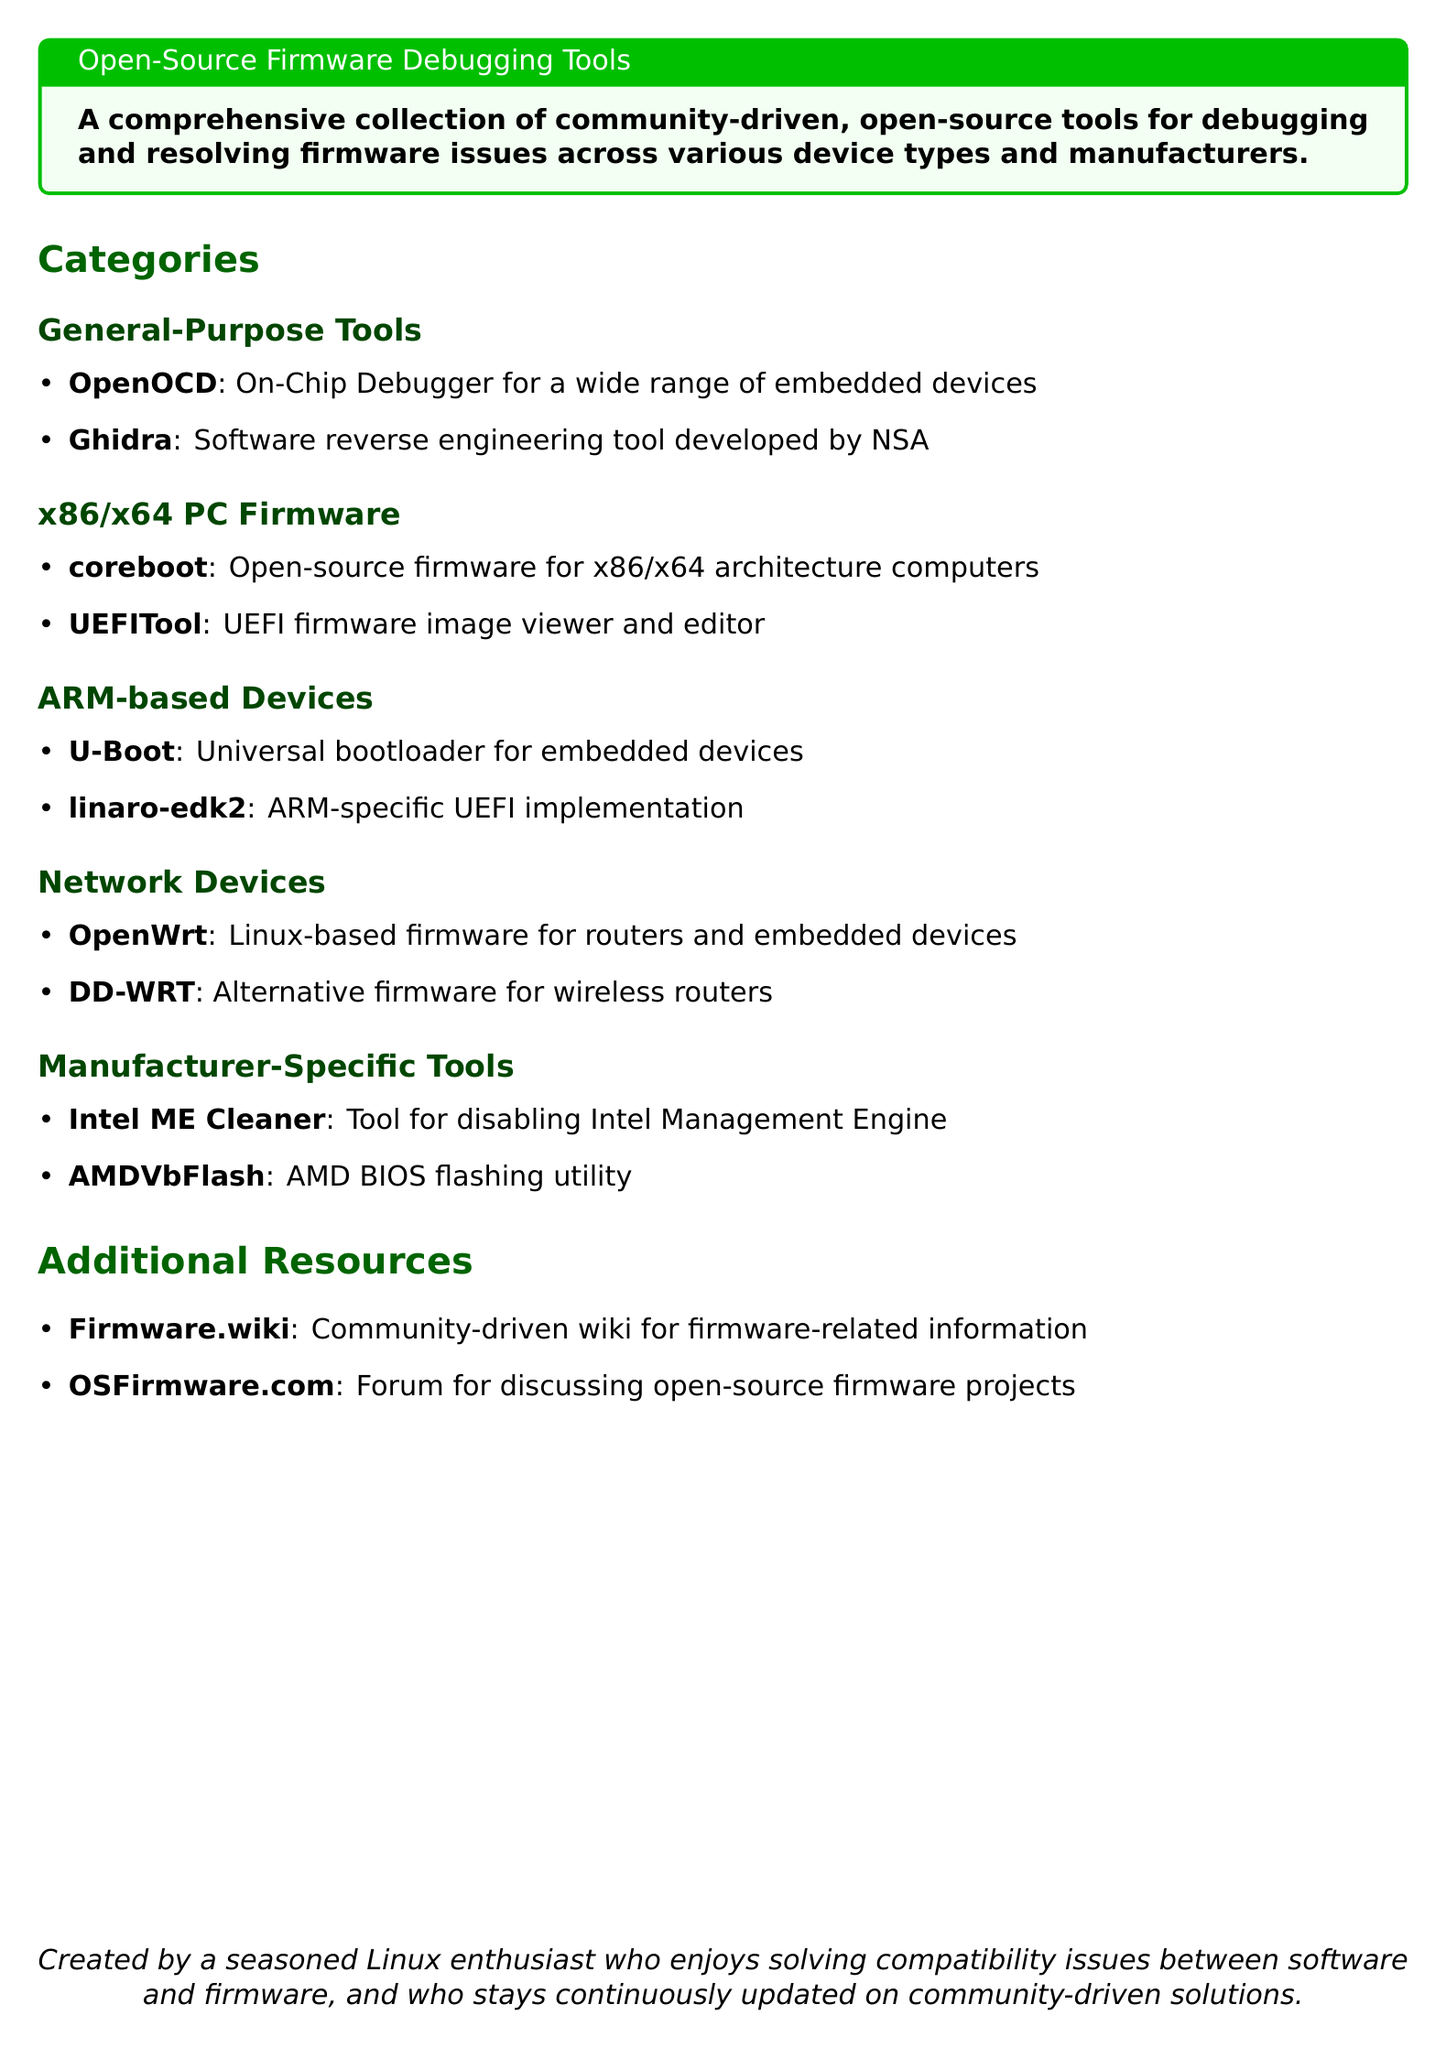What is the title of the document? The title is provided in the header of the document and describes the content, which is "Open-Source Firmware Debugging Tools."
Answer: Open-Source Firmware Debugging Tools How many categories are listed in the document? The document sections mention five distinct categories for tools, which include General-Purpose Tools, x86/x64 PC Firmware, ARM-based Devices, Network Devices, and Manufacturer-Specific Tools.
Answer: 5 Name a general-purpose tool mentioned in the document. The general-purpose tools section lists "OpenOCD" as one of the tools for debugging embedded devices.
Answer: OpenOCD Which tool is used for disabling Intel Management Engine? The document specifies a manufacturer-specific tool for this purpose, which is "Intel ME Cleaner."
Answer: Intel ME Cleaner What type of devices is "OpenWrt" designed for? The document categorizes "OpenWrt" under Network Devices, indicating its use for routers and embedded devices.
Answer: Routers and embedded devices What is the URL for community-driven firmware-related information? The document references a specific resource, which is "Firmware.wiki," for this information.
Answer: Firmware.wiki Which firmware is an open-source solution for x86/x64 architecture computers? The document lists "coreboot" as the open-source firmware solution for this architecture.
Answer: coreboot Name one tool for ARM-based devices. The document includes "U-Boot" as a tool specifically for ARM-based devices.
Answer: U-Boot How is the document introduced? The document starts with a tcolorbox highlighting its purpose as a collection of community-driven tools for firmware debugging.
Answer: A comprehensive collection of community-driven, open-source tools for debugging and resolving firmware issues across various device types and manufacturers 